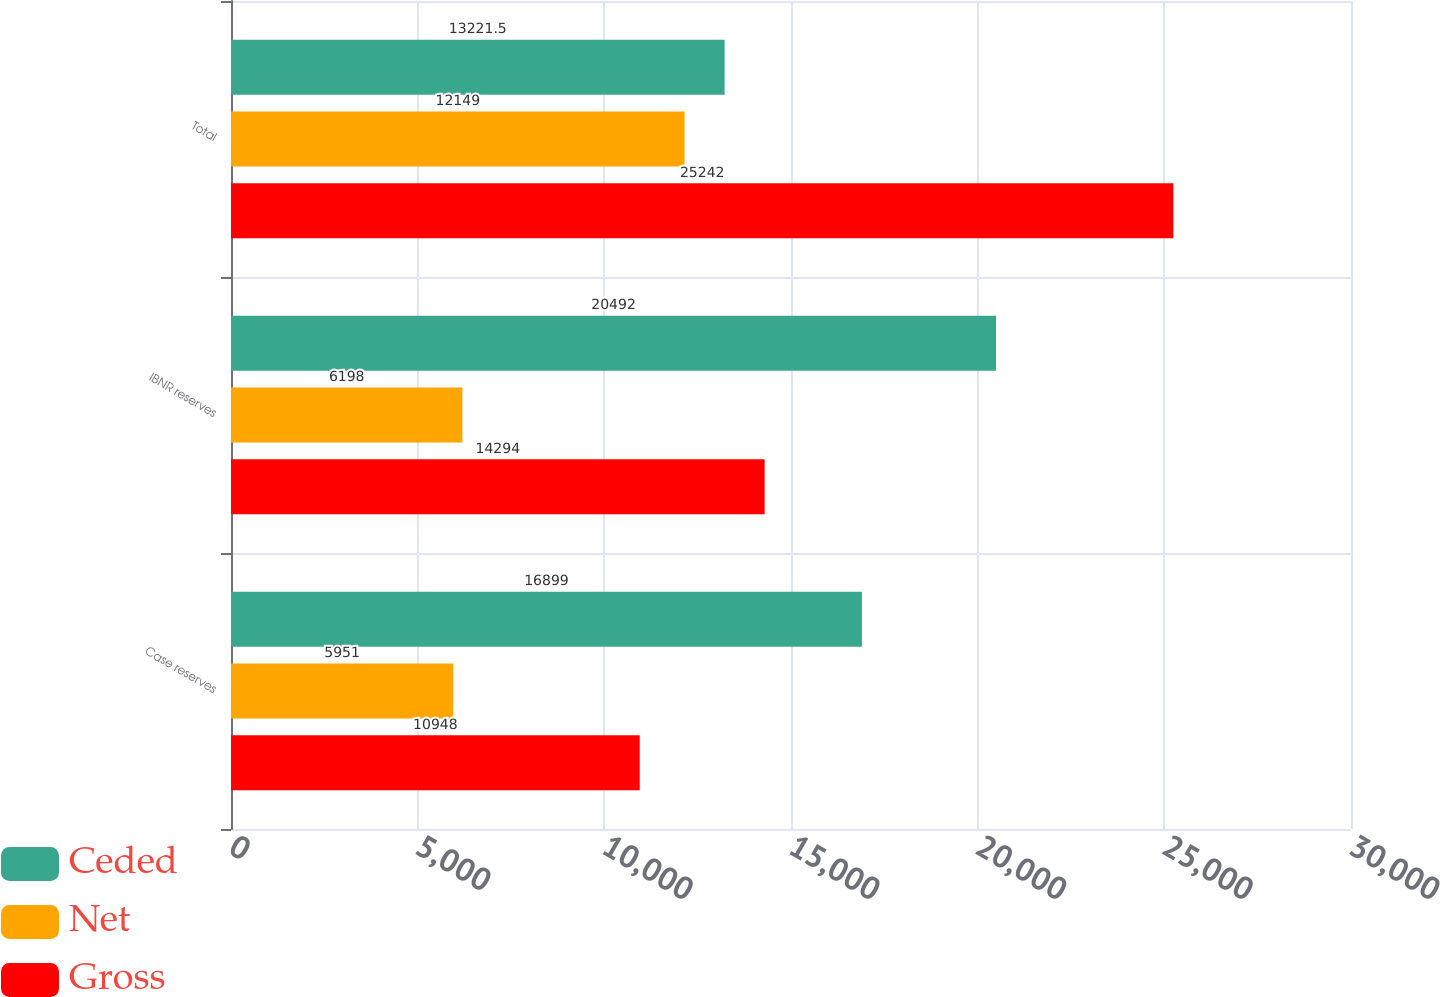<chart> <loc_0><loc_0><loc_500><loc_500><stacked_bar_chart><ecel><fcel>Case reserves<fcel>IBNR reserves<fcel>Total<nl><fcel>Ceded<fcel>16899<fcel>20492<fcel>13221.5<nl><fcel>Net<fcel>5951<fcel>6198<fcel>12149<nl><fcel>Gross<fcel>10948<fcel>14294<fcel>25242<nl></chart> 